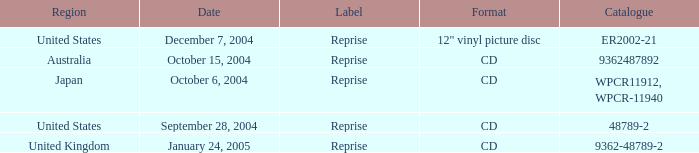Help me parse the entirety of this table. {'header': ['Region', 'Date', 'Label', 'Format', 'Catalogue'], 'rows': [['United States', 'December 7, 2004', 'Reprise', '12" vinyl picture disc', 'ER2002-21'], ['Australia', 'October 15, 2004', 'Reprise', 'CD', '9362487892'], ['Japan', 'October 6, 2004', 'Reprise', 'CD', 'WPCR11912, WPCR-11940'], ['United States', 'September 28, 2004', 'Reprise', 'CD', '48789-2'], ['United Kingdom', 'January 24, 2005', 'Reprise', 'CD', '9362-48789-2']]} Name the october 15, 2004 catalogue 9362487892.0. 